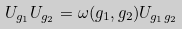Convert formula to latex. <formula><loc_0><loc_0><loc_500><loc_500>U _ { g _ { 1 } } U _ { g _ { 2 } } = \omega ( g _ { 1 } , g _ { 2 } ) U _ { g _ { 1 } g _ { 2 } }</formula> 